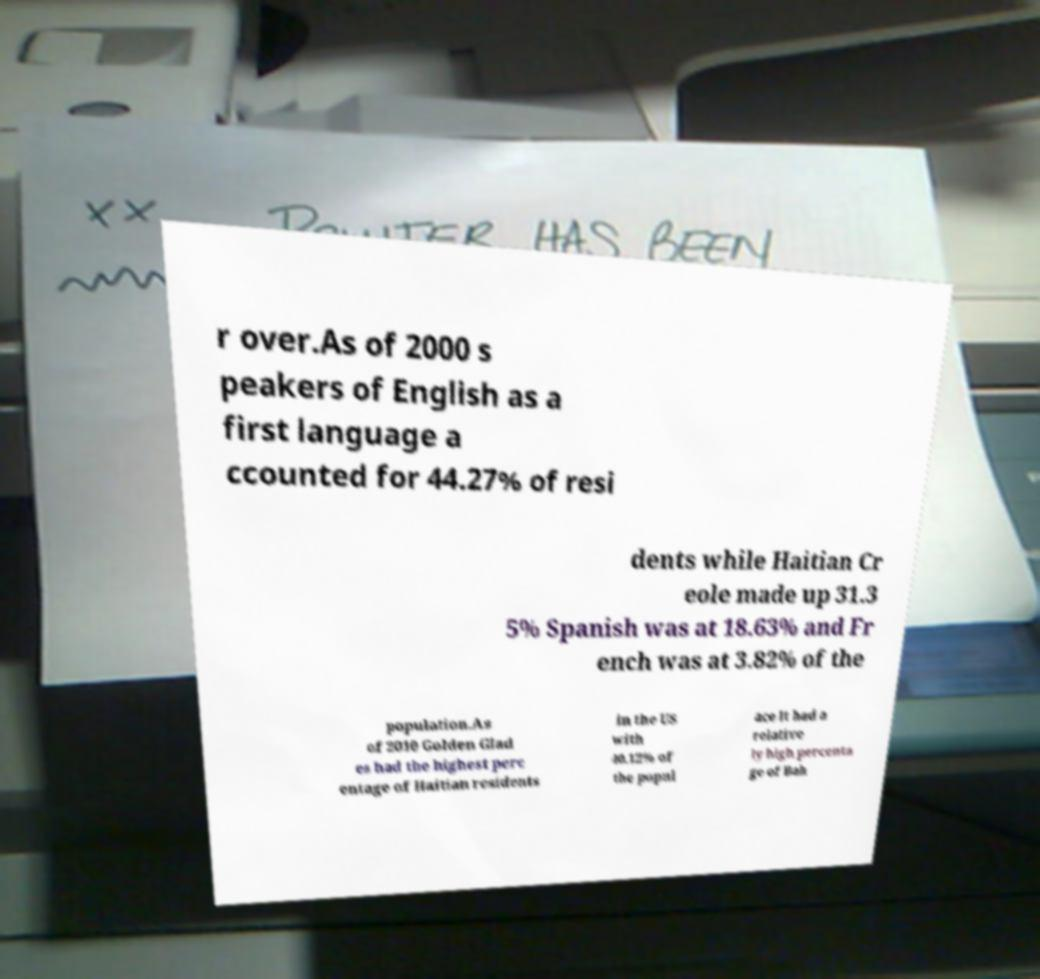There's text embedded in this image that I need extracted. Can you transcribe it verbatim? r over.As of 2000 s peakers of English as a first language a ccounted for 44.27% of resi dents while Haitian Cr eole made up 31.3 5% Spanish was at 18.63% and Fr ench was at 3.82% of the population.As of 2010 Golden Glad es had the highest perc entage of Haitian residents in the US with 40.12% of the popul ace It had a relative ly high percenta ge of Bah 